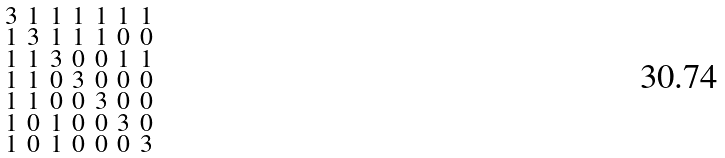Convert formula to latex. <formula><loc_0><loc_0><loc_500><loc_500>\begin{smallmatrix} 3 & 1 & 1 & 1 & 1 & 1 & 1 \\ 1 & 3 & 1 & 1 & 1 & 0 & 0 \\ 1 & 1 & 3 & 0 & 0 & 1 & 1 \\ 1 & 1 & 0 & 3 & 0 & 0 & 0 \\ 1 & 1 & 0 & 0 & 3 & 0 & 0 \\ 1 & 0 & 1 & 0 & 0 & 3 & 0 \\ 1 & 0 & 1 & 0 & 0 & 0 & 3 \end{smallmatrix}</formula> 